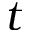Convert formula to latex. <formula><loc_0><loc_0><loc_500><loc_500>t</formula> 